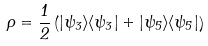<formula> <loc_0><loc_0><loc_500><loc_500>\rho = \frac { 1 } { 2 } \left ( | \psi _ { 3 } \rangle \langle \psi _ { 3 } | + | \psi _ { 5 } \rangle \langle \psi _ { 5 } | \right )</formula> 